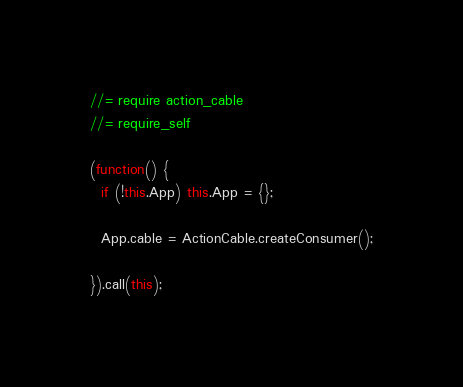Convert code to text. <code><loc_0><loc_0><loc_500><loc_500><_JavaScript_>//= require action_cable
//= require_self

(function() {
  if (!this.App) this.App = {};

  App.cable = ActionCable.createConsumer();

}).call(this);
</code> 